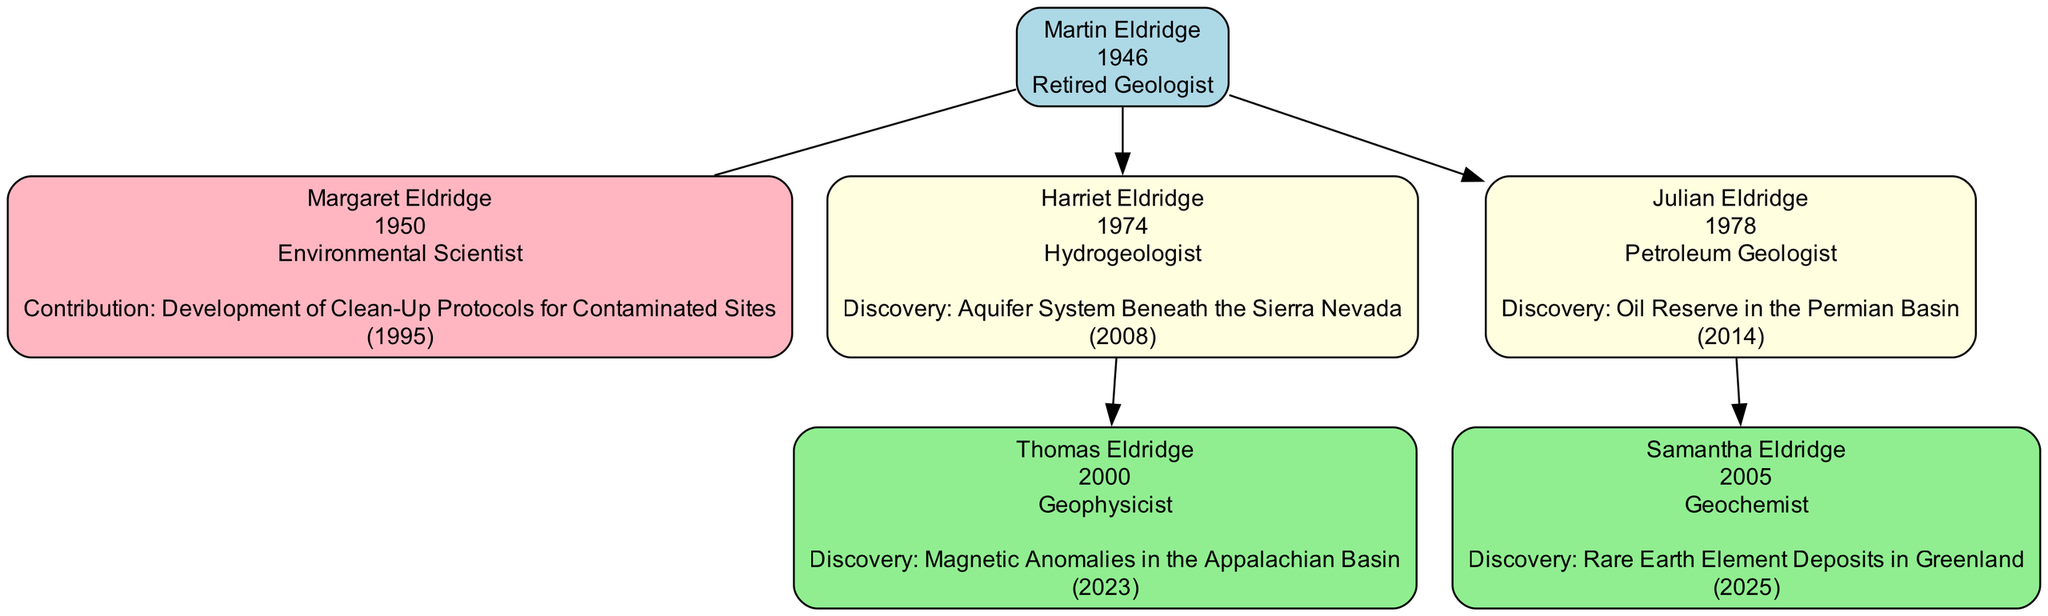What's the name of the oldest family member? The oldest family member is Martin Eldridge, who was born in 1946.
Answer: Martin Eldridge How many children does Martin Eldridge have? Martin Eldridge has two children: Harriet Eldridge and Julian Eldridge.
Answer: 2 What profession does Harriet Eldridge have? Harriet Eldridge is a Hydrogeologist, which is specified next to her name in the diagram.
Answer: Hydrogeologist Which child of Martin Eldridge made a discovery in 2014? Julian Eldridge made a discovery in 2014, specifically about an Oil Reserve in the Permian Basin.
Answer: Julian Eldridge What is the major discovery of Thomas Eldridge? Thomas Eldridge's major discovery is "Magnetic Anomalies in the Appalachian Basin" made in 2023.
Answer: Magnetic Anomalies in the Appalachian Basin Who developed cleanup protocols for contaminated sites? The major contribution regarding cleanup protocols was made by Margaret Eldridge in 1995.
Answer: Margaret Eldridge Which family member is a Geochemist? Samantha Eldridge is a Geochemist, as shown in the diagram.
Answer: Samantha Eldridge What discovery did Harriet Eldridge make? Harriet Eldridge discovered an "Aquifer System Beneath the Sierra Nevada" in 2008.
Answer: Aquifer System Beneath the Sierra Nevada How many professions are represented in the family tree? The family tree includes four different professions: Retired Geologist, Hydrogeologist, Petroleum Geologist, and Geochemist.
Answer: 4 